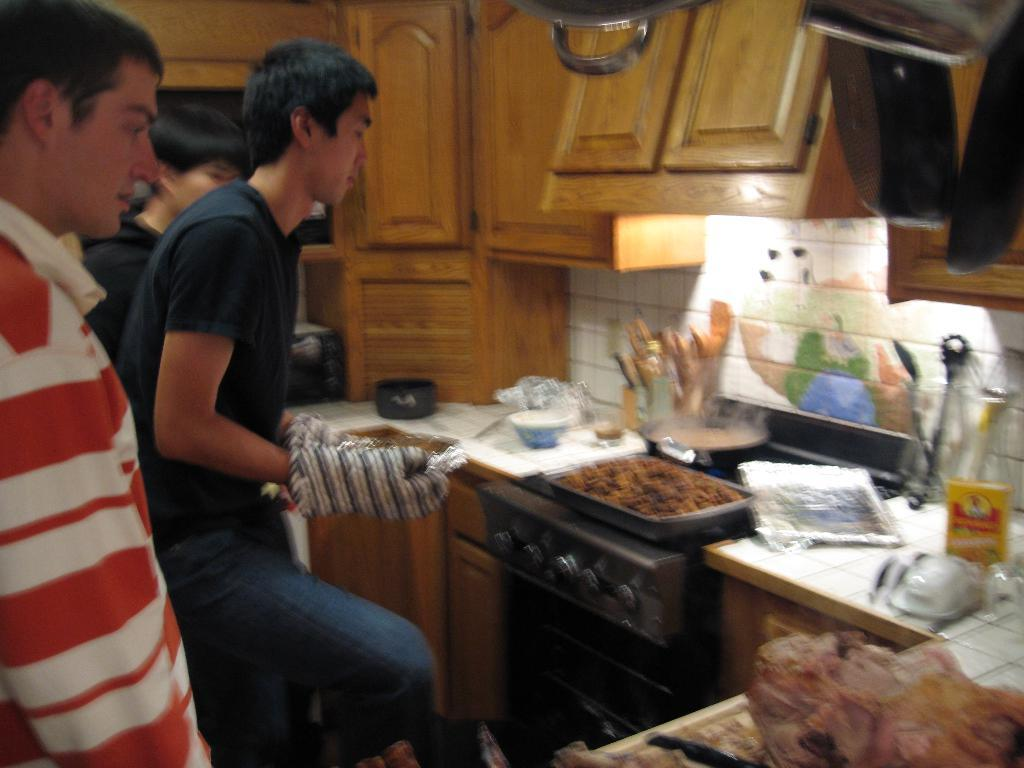How many people are in the image? There are people in the image, but the exact number is not specified. What type of wooden object can be seen in the image? There is a wooden object in the image, but its specific nature is not mentioned. What kind of electronic gadget is present in the image? There is an electronic gadget in the image, but its exact type is not described. What is the purpose of the bowl in the image? The purpose of the bowl in the image is not specified. Can you describe the other objects in the image? There are some other objects in the image, but their specific nature is not mentioned. What team is responsible for the rain in the image? There is no mention of rain in the image, so it is not possible to attribute it to a team. 